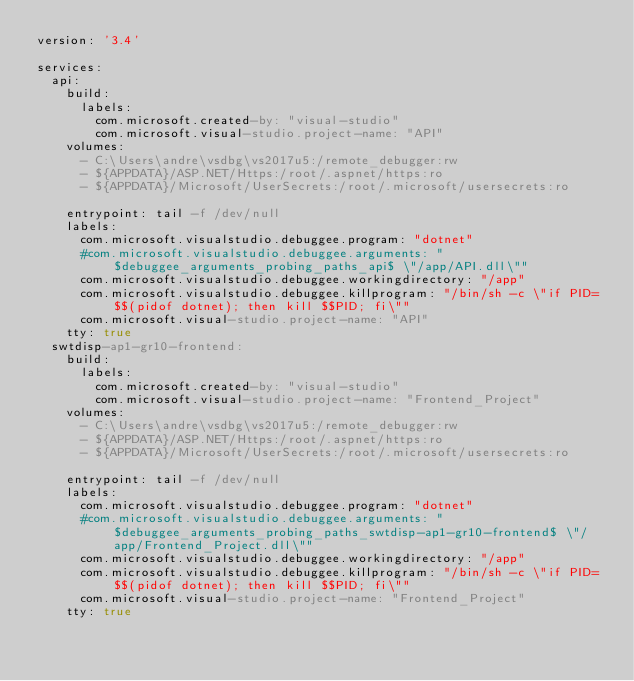Convert code to text. <code><loc_0><loc_0><loc_500><loc_500><_YAML_>version: '3.4'

services:
  api:
    build:
      labels:
        com.microsoft.created-by: "visual-studio"
        com.microsoft.visual-studio.project-name: "API"
    volumes:
      - C:\Users\andre\vsdbg\vs2017u5:/remote_debugger:rw
      - ${APPDATA}/ASP.NET/Https:/root/.aspnet/https:ro
      - ${APPDATA}/Microsoft/UserSecrets:/root/.microsoft/usersecrets:ro

    entrypoint: tail -f /dev/null
    labels:
      com.microsoft.visualstudio.debuggee.program: "dotnet"
      #com.microsoft.visualstudio.debuggee.arguments: " $debuggee_arguments_probing_paths_api$ \"/app/API.dll\""
      com.microsoft.visualstudio.debuggee.workingdirectory: "/app"
      com.microsoft.visualstudio.debuggee.killprogram: "/bin/sh -c \"if PID=$$(pidof dotnet); then kill $$PID; fi\""
      com.microsoft.visual-studio.project-name: "API"
    tty: true
  swtdisp-ap1-gr10-frontend:
    build:
      labels:
        com.microsoft.created-by: "visual-studio"
        com.microsoft.visual-studio.project-name: "Frontend_Project"
    volumes:
      - C:\Users\andre\vsdbg\vs2017u5:/remote_debugger:rw
      - ${APPDATA}/ASP.NET/Https:/root/.aspnet/https:ro
      - ${APPDATA}/Microsoft/UserSecrets:/root/.microsoft/usersecrets:ro

    entrypoint: tail -f /dev/null
    labels:
      com.microsoft.visualstudio.debuggee.program: "dotnet"
      #com.microsoft.visualstudio.debuggee.arguments: " $debuggee_arguments_probing_paths_swtdisp-ap1-gr10-frontend$ \"/app/Frontend_Project.dll\""
      com.microsoft.visualstudio.debuggee.workingdirectory: "/app"
      com.microsoft.visualstudio.debuggee.killprogram: "/bin/sh -c \"if PID=$$(pidof dotnet); then kill $$PID; fi\""
      com.microsoft.visual-studio.project-name: "Frontend_Project"
    tty: true
</code> 